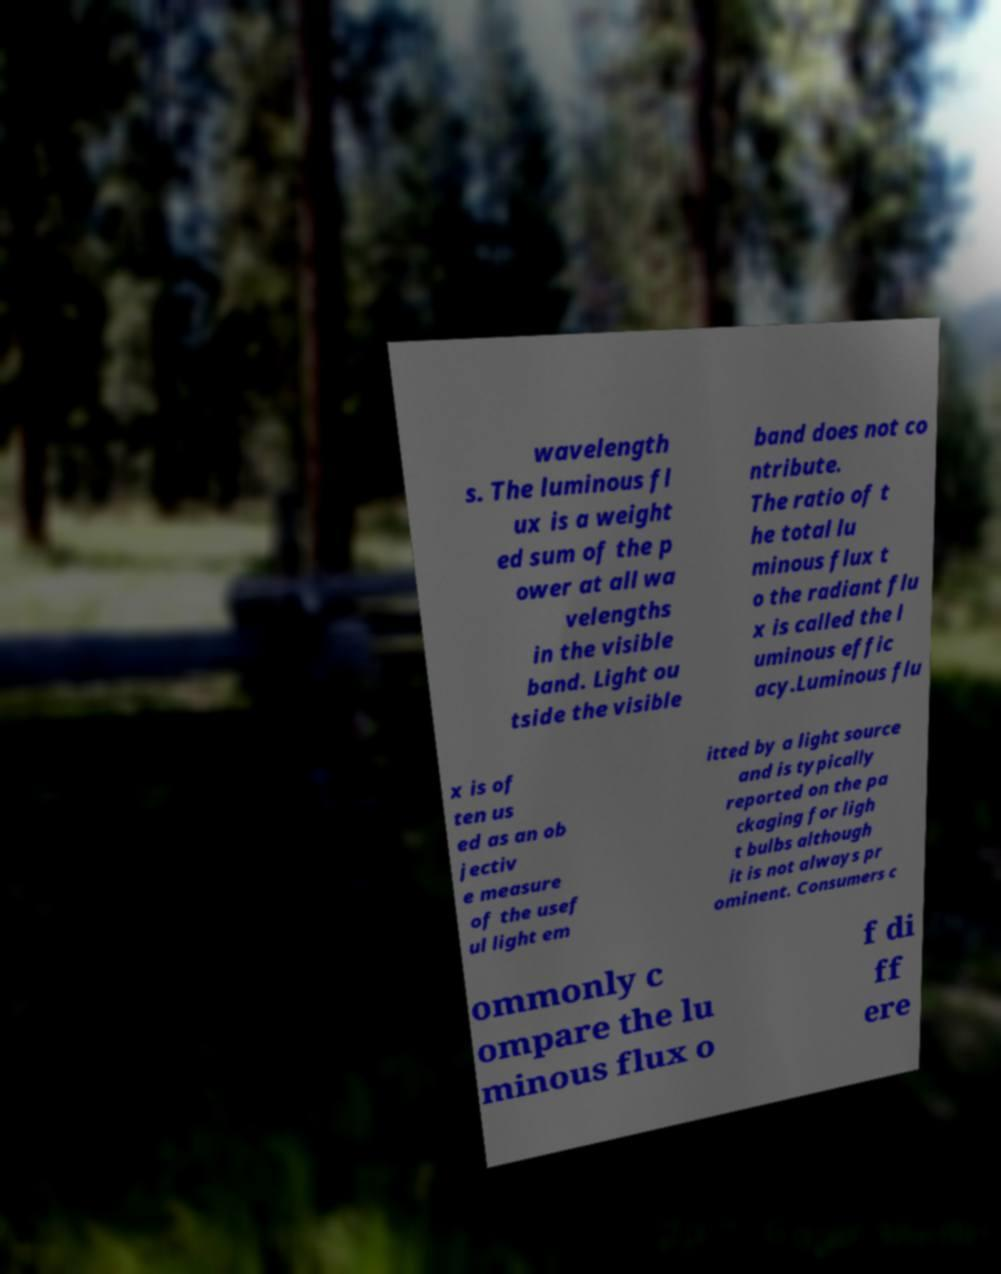Could you extract and type out the text from this image? wavelength s. The luminous fl ux is a weight ed sum of the p ower at all wa velengths in the visible band. Light ou tside the visible band does not co ntribute. The ratio of t he total lu minous flux t o the radiant flu x is called the l uminous effic acy.Luminous flu x is of ten us ed as an ob jectiv e measure of the usef ul light em itted by a light source and is typically reported on the pa ckaging for ligh t bulbs although it is not always pr ominent. Consumers c ommonly c ompare the lu minous flux o f di ff ere 